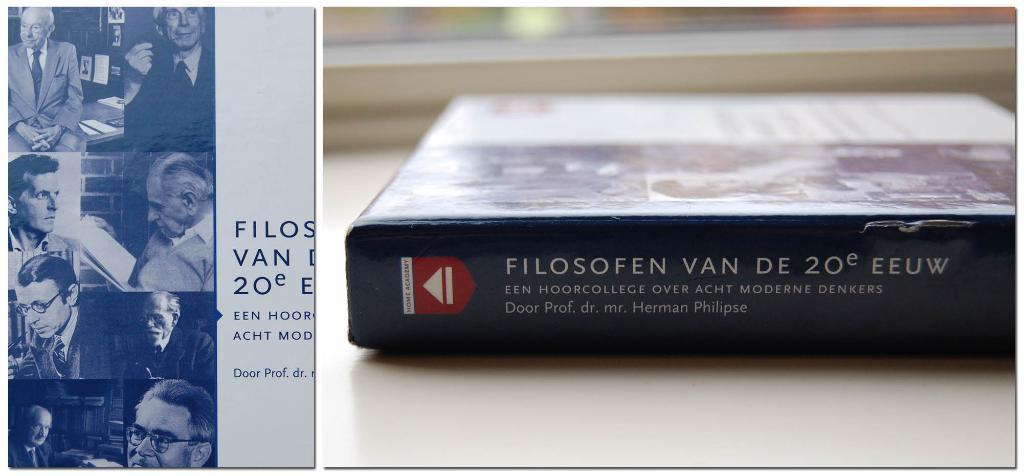<image>
Share a concise interpretation of the image provided. A book sits on a table and it was written by Door Prof. dr. mr. Herman Philipse. 